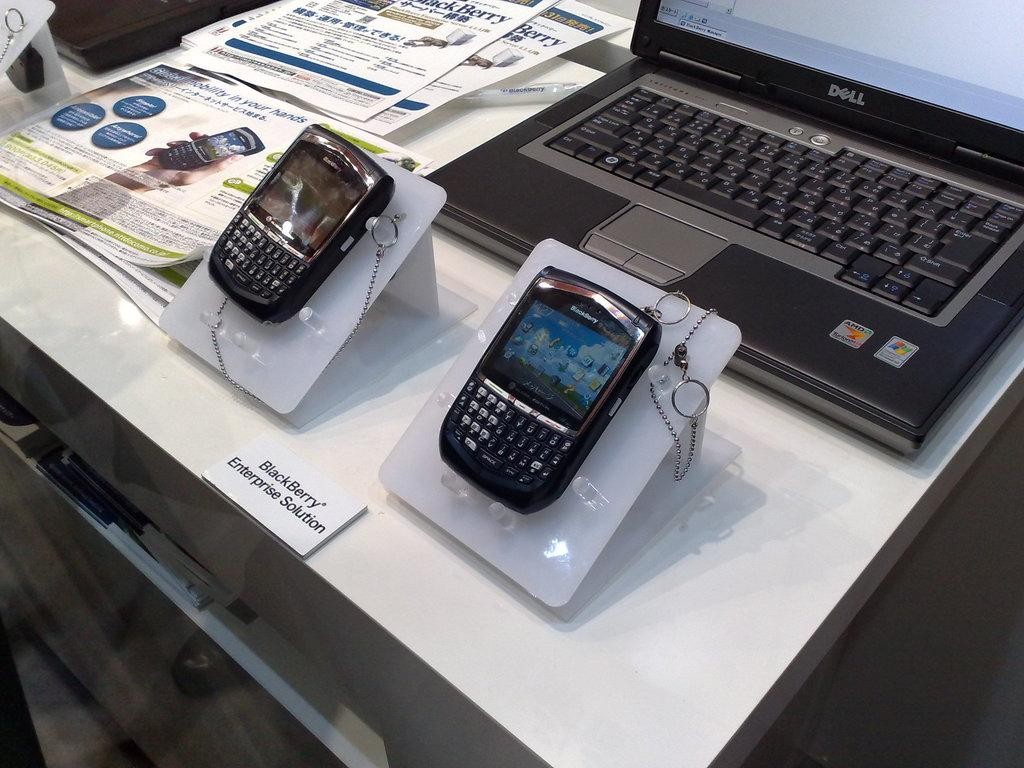<image>
Create a compact narrative representing the image presented. two blackberry enterprise solution phones displayed in front of laptop and next to brochures 